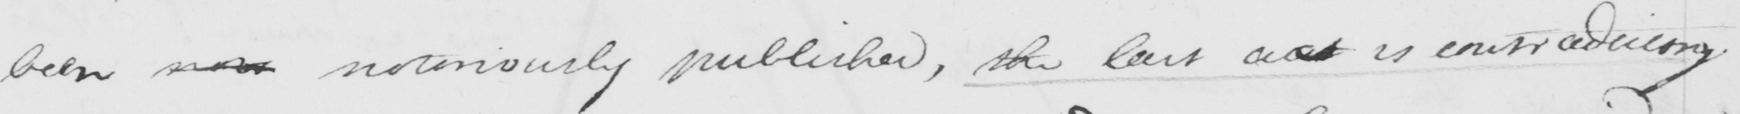Can you tell me what this handwritten text says? been nor notoriously published , the last act is contraducing 